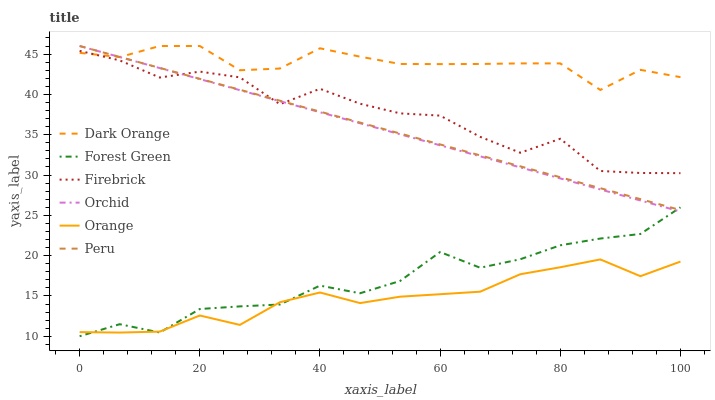Does Orange have the minimum area under the curve?
Answer yes or no. Yes. Does Dark Orange have the maximum area under the curve?
Answer yes or no. Yes. Does Firebrick have the minimum area under the curve?
Answer yes or no. No. Does Firebrick have the maximum area under the curve?
Answer yes or no. No. Is Peru the smoothest?
Answer yes or no. Yes. Is Firebrick the roughest?
Answer yes or no. Yes. Is Forest Green the smoothest?
Answer yes or no. No. Is Forest Green the roughest?
Answer yes or no. No. Does Forest Green have the lowest value?
Answer yes or no. Yes. Does Firebrick have the lowest value?
Answer yes or no. No. Does Orchid have the highest value?
Answer yes or no. Yes. Does Firebrick have the highest value?
Answer yes or no. No. Is Orange less than Peru?
Answer yes or no. Yes. Is Firebrick greater than Forest Green?
Answer yes or no. Yes. Does Peru intersect Forest Green?
Answer yes or no. Yes. Is Peru less than Forest Green?
Answer yes or no. No. Is Peru greater than Forest Green?
Answer yes or no. No. Does Orange intersect Peru?
Answer yes or no. No. 